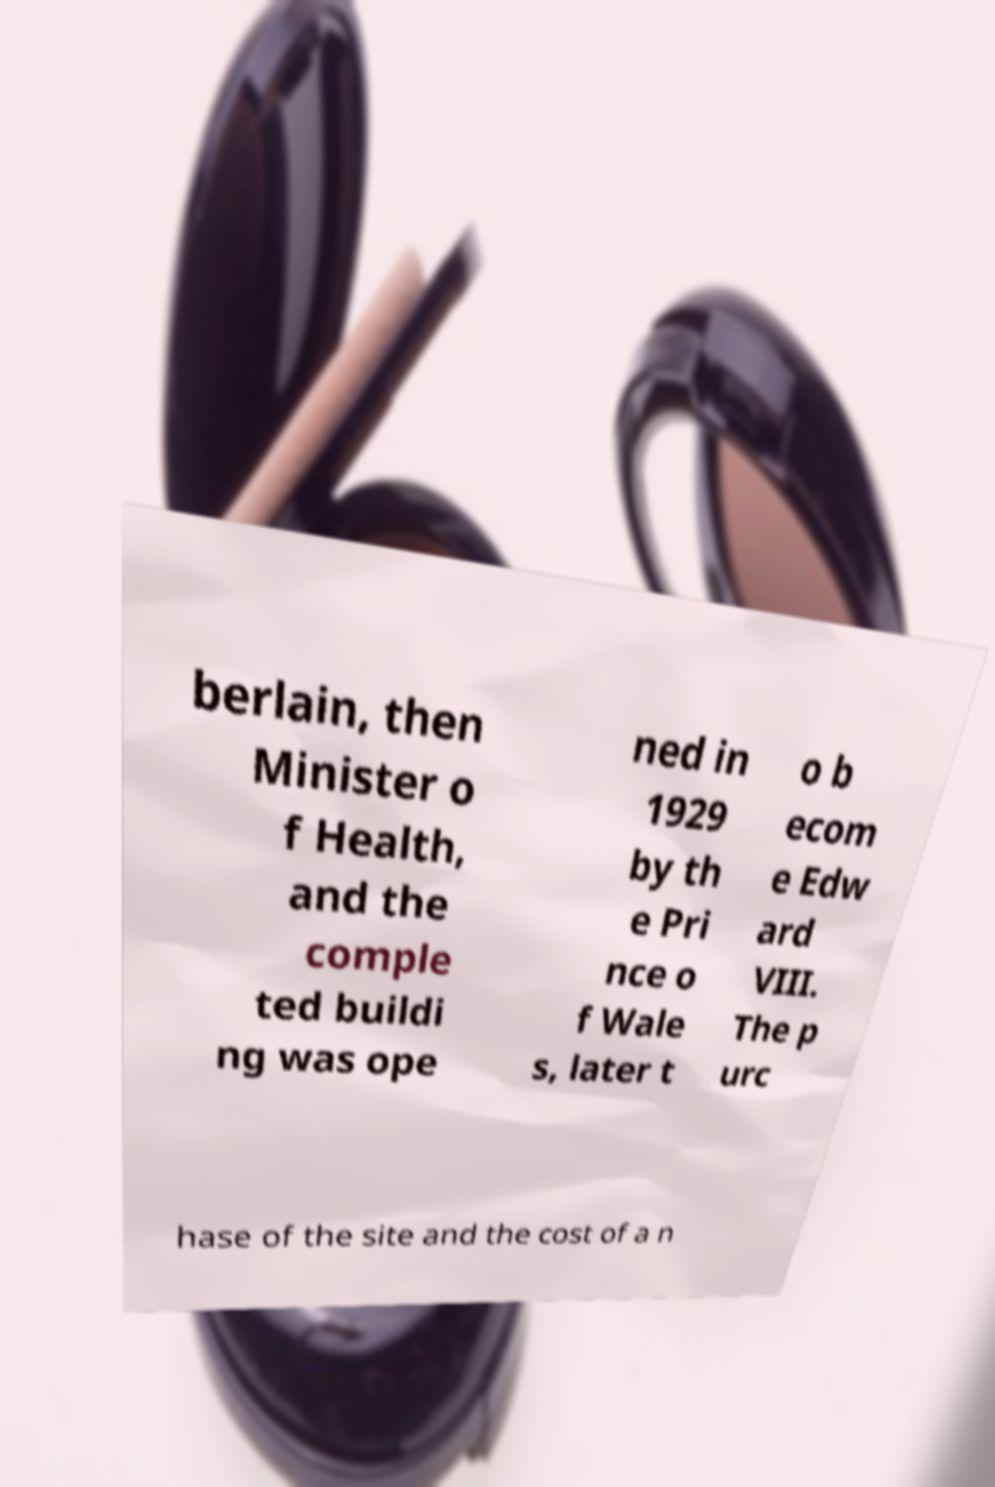Please read and relay the text visible in this image. What does it say? berlain, then Minister o f Health, and the comple ted buildi ng was ope ned in 1929 by th e Pri nce o f Wale s, later t o b ecom e Edw ard VIII. The p urc hase of the site and the cost of a n 